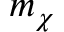<formula> <loc_0><loc_0><loc_500><loc_500>m _ { \chi }</formula> 